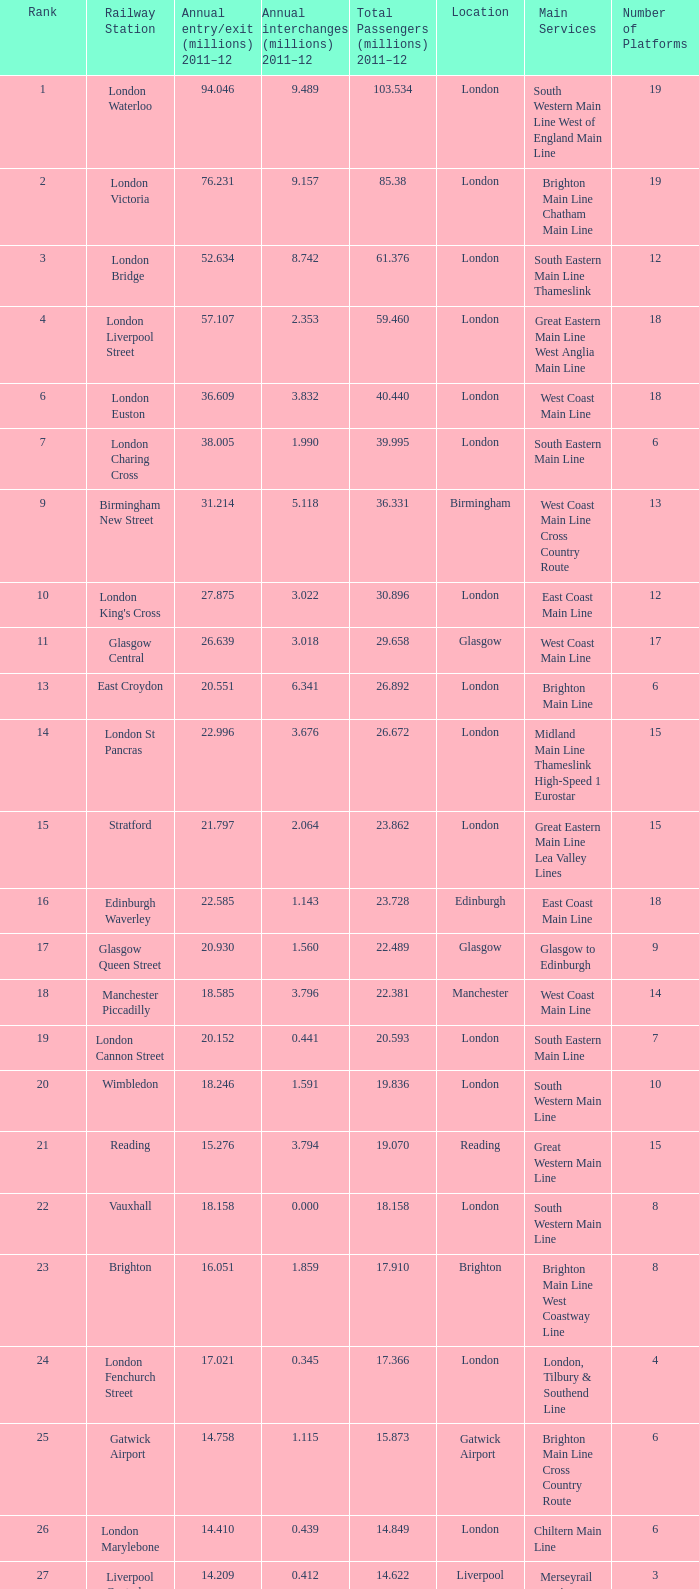What is the main service for the station with 14.849 million passengers 2011-12?  Chiltern Main Line. 